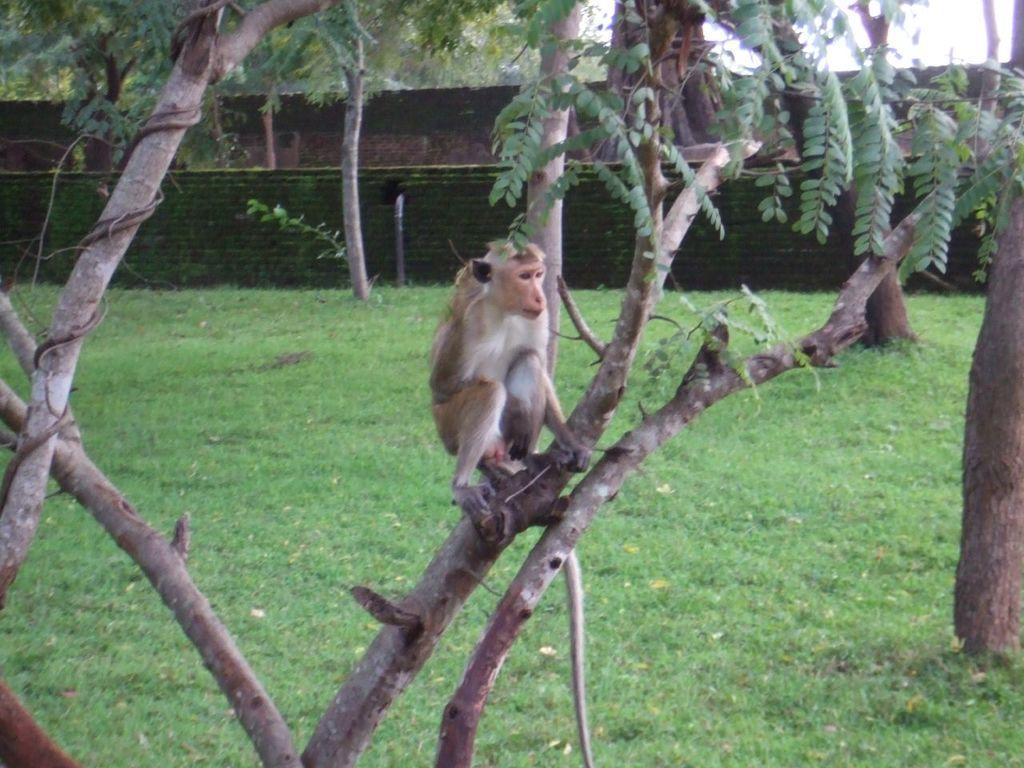How would you summarize this image in a sentence or two? In this image in the foreground there is one monkey sitting on a tree, and at the bottom there is grass. In the background there is a wall and fence. 